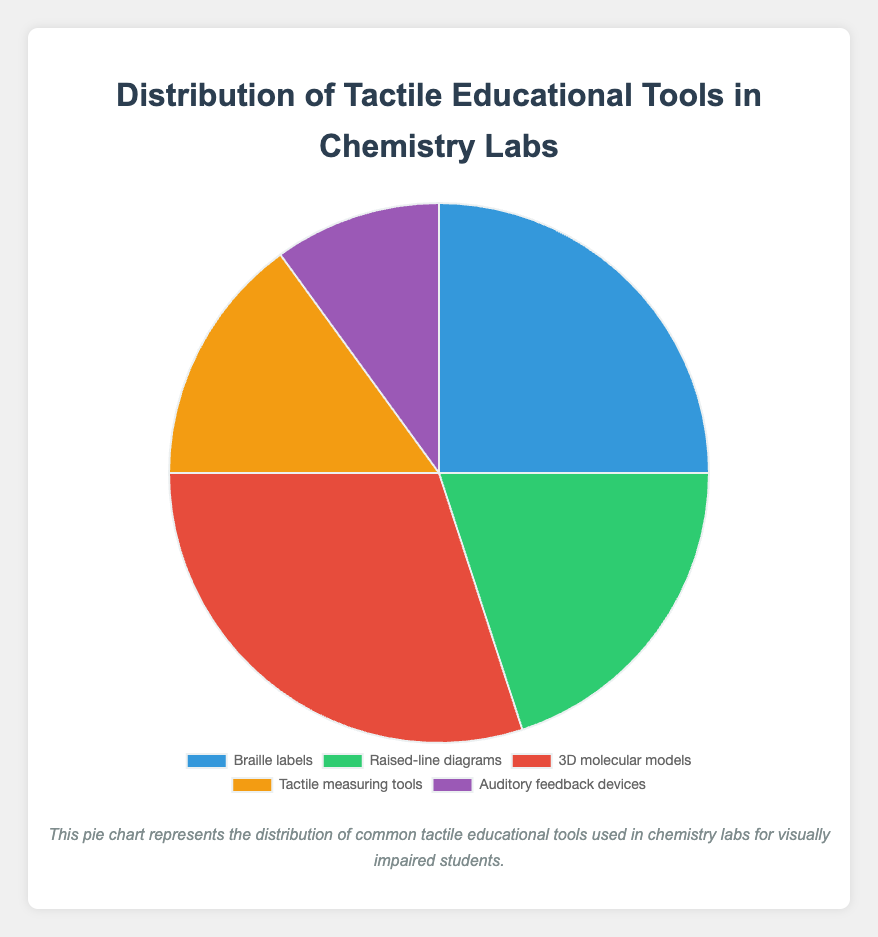What percentage of the tools are 3D molecular models? The chart shows that 3D molecular models make up 30% of the tools used.
Answer: 30% Which tool is used more: Braille labels or auditory feedback devices? According to the chart, Braille labels are used more (25%) compared to auditory feedback devices (10%).
Answer: Braille labels What is the total percentage of tools that involve tactile (touch) feedback, such as Braille labels, raised-line diagrams, 3D molecular models, and tactile measuring tools? Sum the percentages of Braille labels (25%), raised-line diagrams (20%), 3D molecular models (30%), and tactile measuring tools (15%). The total is 25 + 20 + 30 + 15 = 90%.
Answer: 90% Are 3D molecular models used more or less than both raised-line diagrams and auditory feedback devices combined? Combine the percentages of raised-line diagrams (20%) and auditory feedback devices (10%), which is 20 + 10 = 30%. Since 3D molecular models are also 30%, they are used equally.
Answer: Equally Which tool accounts for the smallest percentage of use? The smallest percentage is 10%, which corresponds to auditory feedback devices.
Answer: Auditory feedback devices What is the ratio of the usage percentage of 3D molecular models to tactile measuring tools? The percentage of 3D molecular models is 30%, and for tactile measuring tools, it is 15%. The ratio is 30:15, which simplifies to 2:1.
Answer: 2:1 Is the percentage of Braille labels and raised-line diagrams combined greater than the percentage of 3D molecular models alone? Combine the percentages of Braille labels (25%) and raised-line diagrams (20%), which is 25 + 20 = 45%. This is greater than the percentage of 3D molecular models (30%).
Answer: Yes If you were to create a pie chart segment that represents all tools except 3D molecular models, what would be the combined percentage? Exclude the percentage of 3D molecular models (30%) from the total (100%), which gives 100 - 30 = 70%.
Answer: 70% What is the difference in percentage between tactile measuring tools and auditory feedback devices? The percentage of tactile measuring tools is 15%, and for auditory feedback devices, it is 10%. The difference is 15 - 10 = 5%.
Answer: 5% 